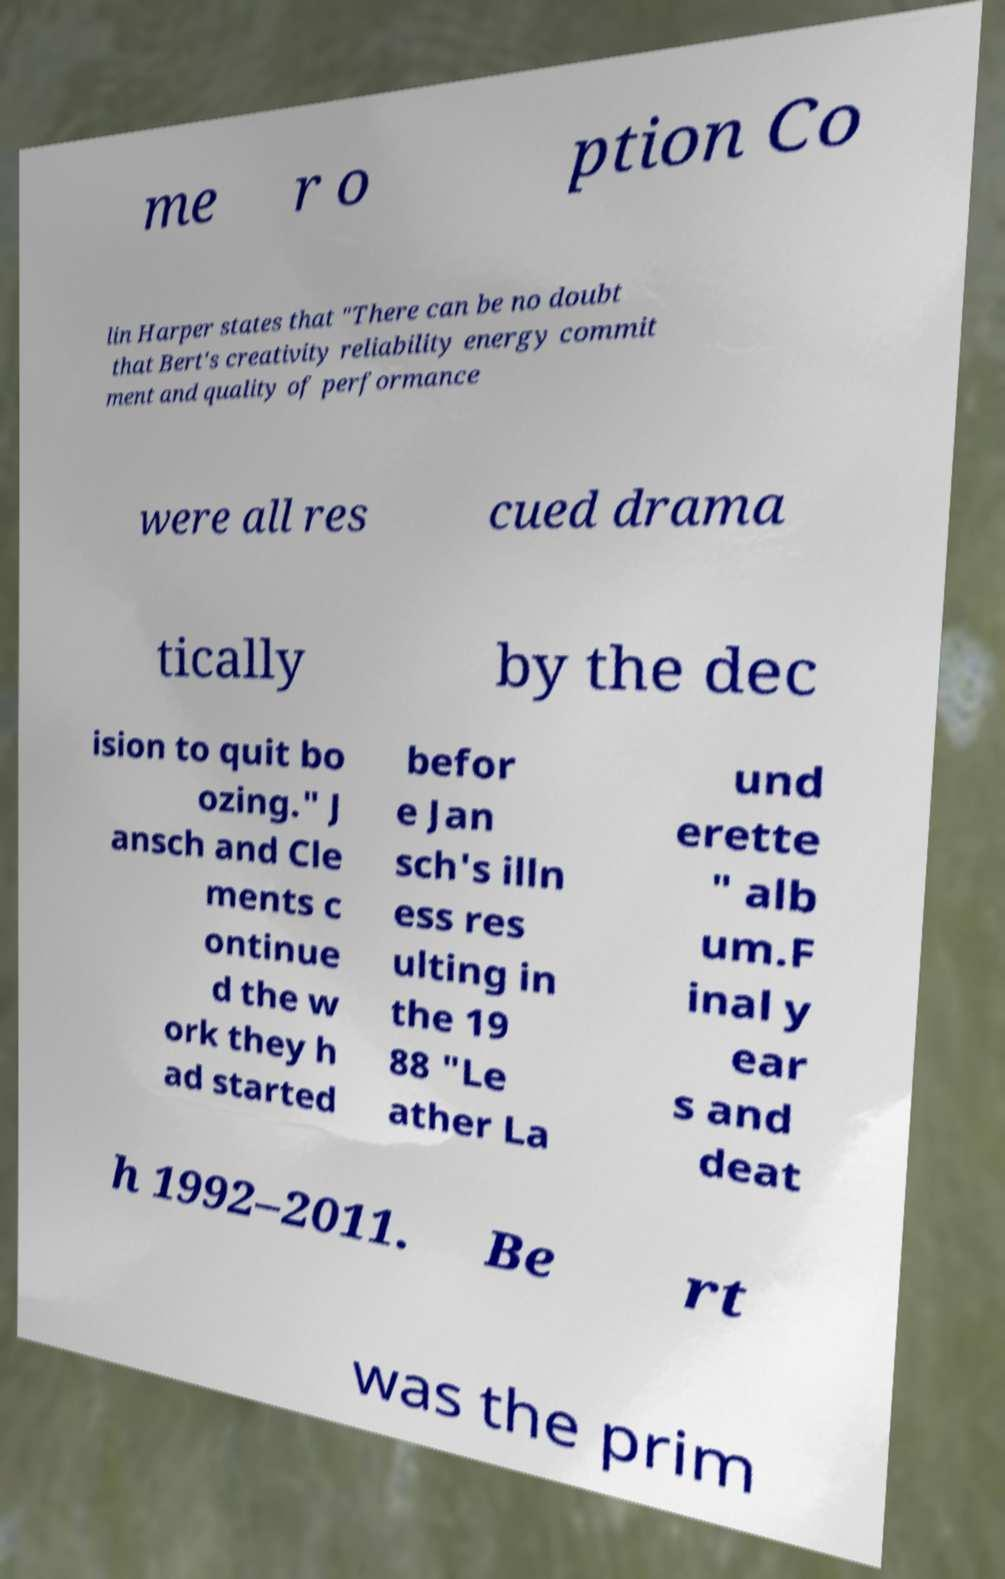Please read and relay the text visible in this image. What does it say? me r o ption Co lin Harper states that "There can be no doubt that Bert's creativity reliability energy commit ment and quality of performance were all res cued drama tically by the dec ision to quit bo ozing." J ansch and Cle ments c ontinue d the w ork they h ad started befor e Jan sch's illn ess res ulting in the 19 88 "Le ather La und erette " alb um.F inal y ear s and deat h 1992–2011. Be rt was the prim 